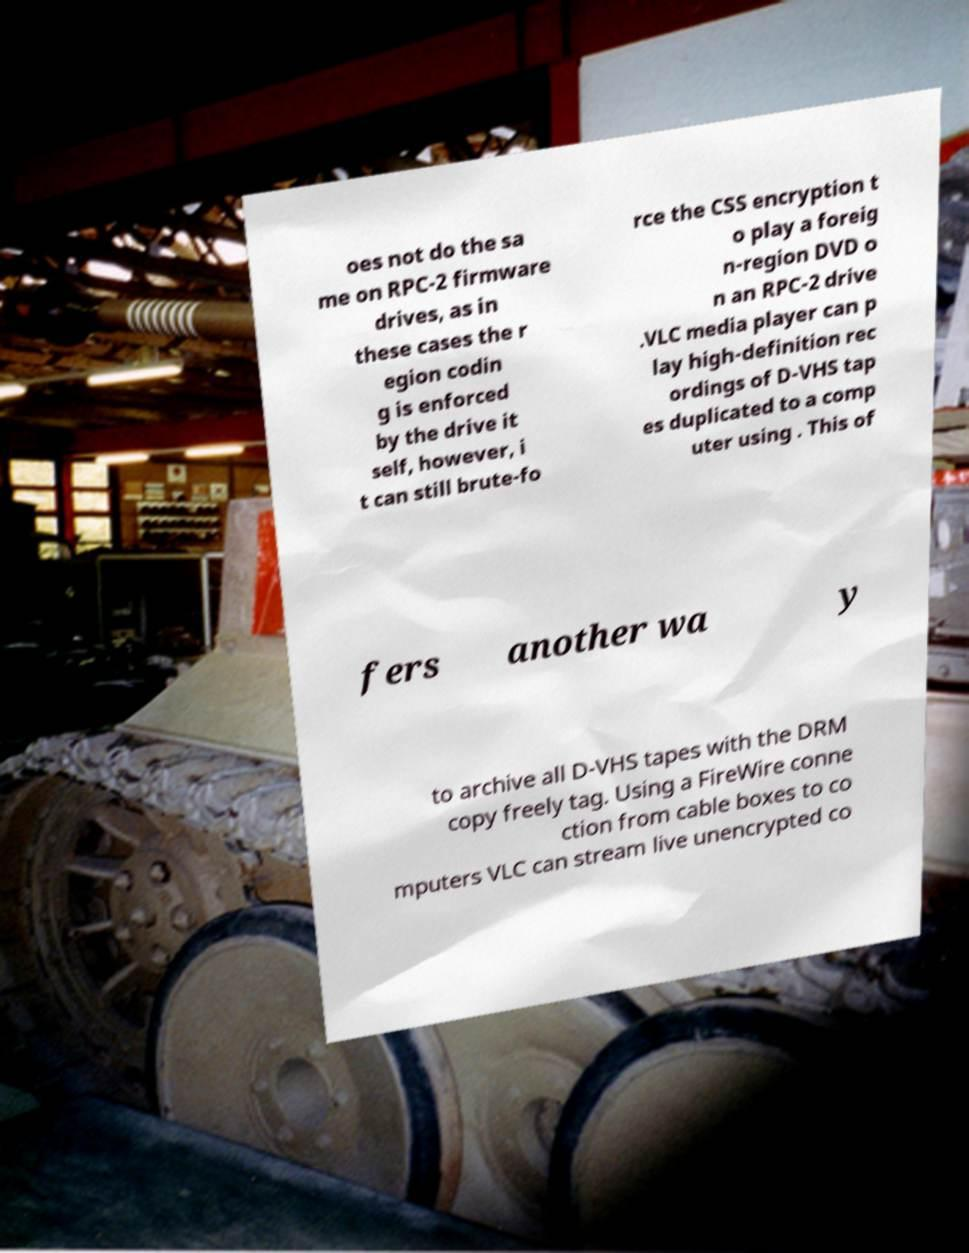Can you read and provide the text displayed in the image?This photo seems to have some interesting text. Can you extract and type it out for me? oes not do the sa me on RPC-2 firmware drives, as in these cases the r egion codin g is enforced by the drive it self, however, i t can still brute-fo rce the CSS encryption t o play a foreig n-region DVD o n an RPC-2 drive .VLC media player can p lay high-definition rec ordings of D-VHS tap es duplicated to a comp uter using . This of fers another wa y to archive all D-VHS tapes with the DRM copy freely tag. Using a FireWire conne ction from cable boxes to co mputers VLC can stream live unencrypted co 